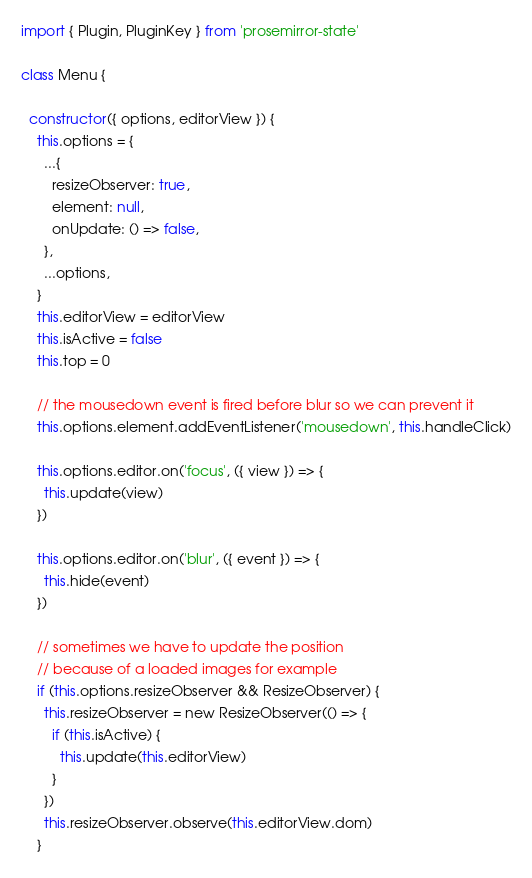Convert code to text. <code><loc_0><loc_0><loc_500><loc_500><_JavaScript_>import { Plugin, PluginKey } from 'prosemirror-state'

class Menu {

  constructor({ options, editorView }) {
    this.options = {
      ...{
        resizeObserver: true,
        element: null,
        onUpdate: () => false,
      },
      ...options,
    }
    this.editorView = editorView
    this.isActive = false
    this.top = 0

    // the mousedown event is fired before blur so we can prevent it
    this.options.element.addEventListener('mousedown', this.handleClick)

    this.options.editor.on('focus', ({ view }) => {
      this.update(view)
    })

    this.options.editor.on('blur', ({ event }) => {
      this.hide(event)
    })

    // sometimes we have to update the position
    // because of a loaded images for example
    if (this.options.resizeObserver && ResizeObserver) {
      this.resizeObserver = new ResizeObserver(() => {
        if (this.isActive) {
          this.update(this.editorView)
        }
      })
      this.resizeObserver.observe(this.editorView.dom)
    }</code> 